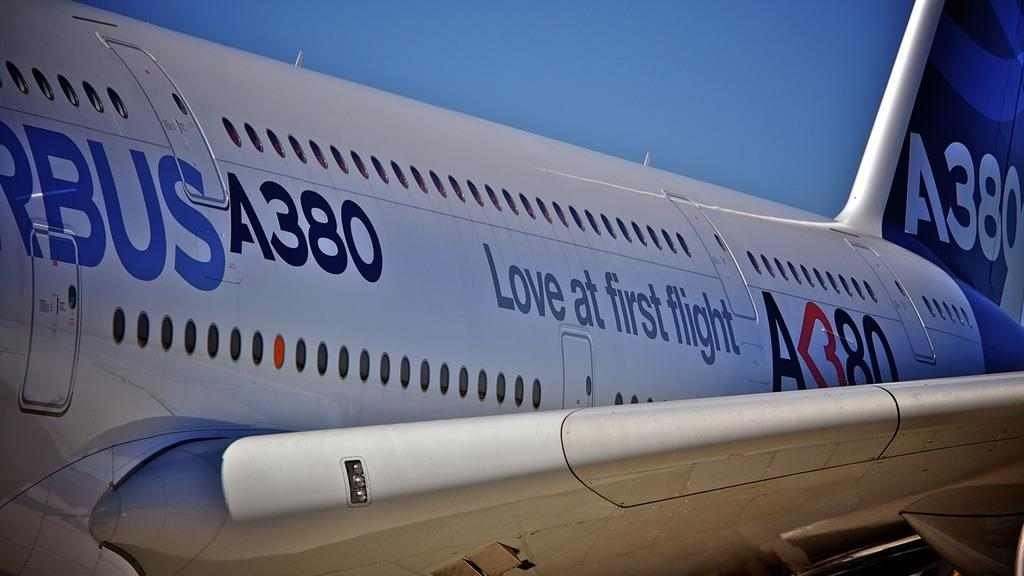<image>
Give a short and clear explanation of the subsequent image. The A380 airplane is getting ready to take off from the airport. 